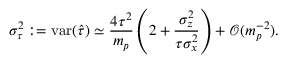<formula> <loc_0><loc_0><loc_500><loc_500>\sigma _ { \tau } ^ { 2 } \colon = v a r ( \widehat { \tau } ) \simeq \frac { 4 \tau ^ { 2 } } { m _ { p } } \left ( 2 + \frac { \sigma _ { z } ^ { 2 } } { \tau \sigma _ { x } ^ { 2 } } \right ) + \mathcal { O } ( m _ { p } ^ { - 2 } ) .</formula> 